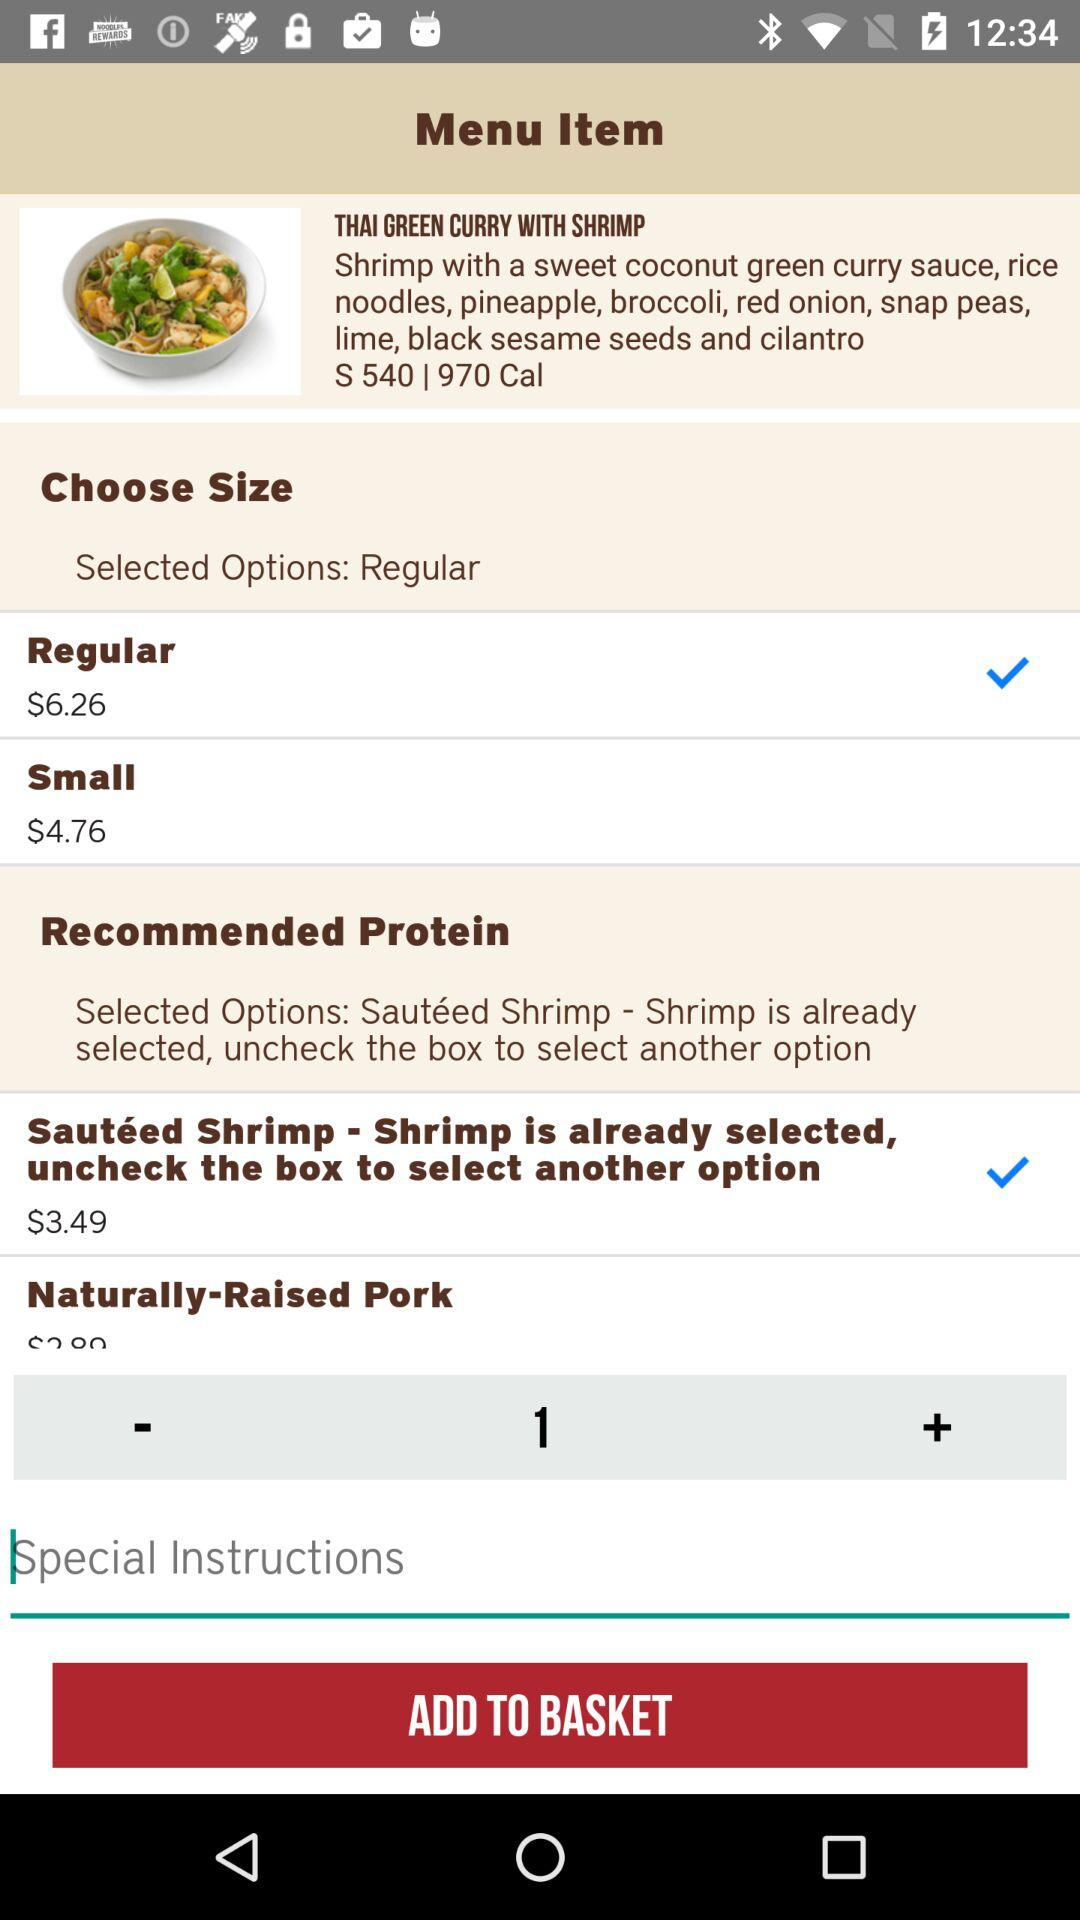Which size is selected? The selected size is "Regular". 